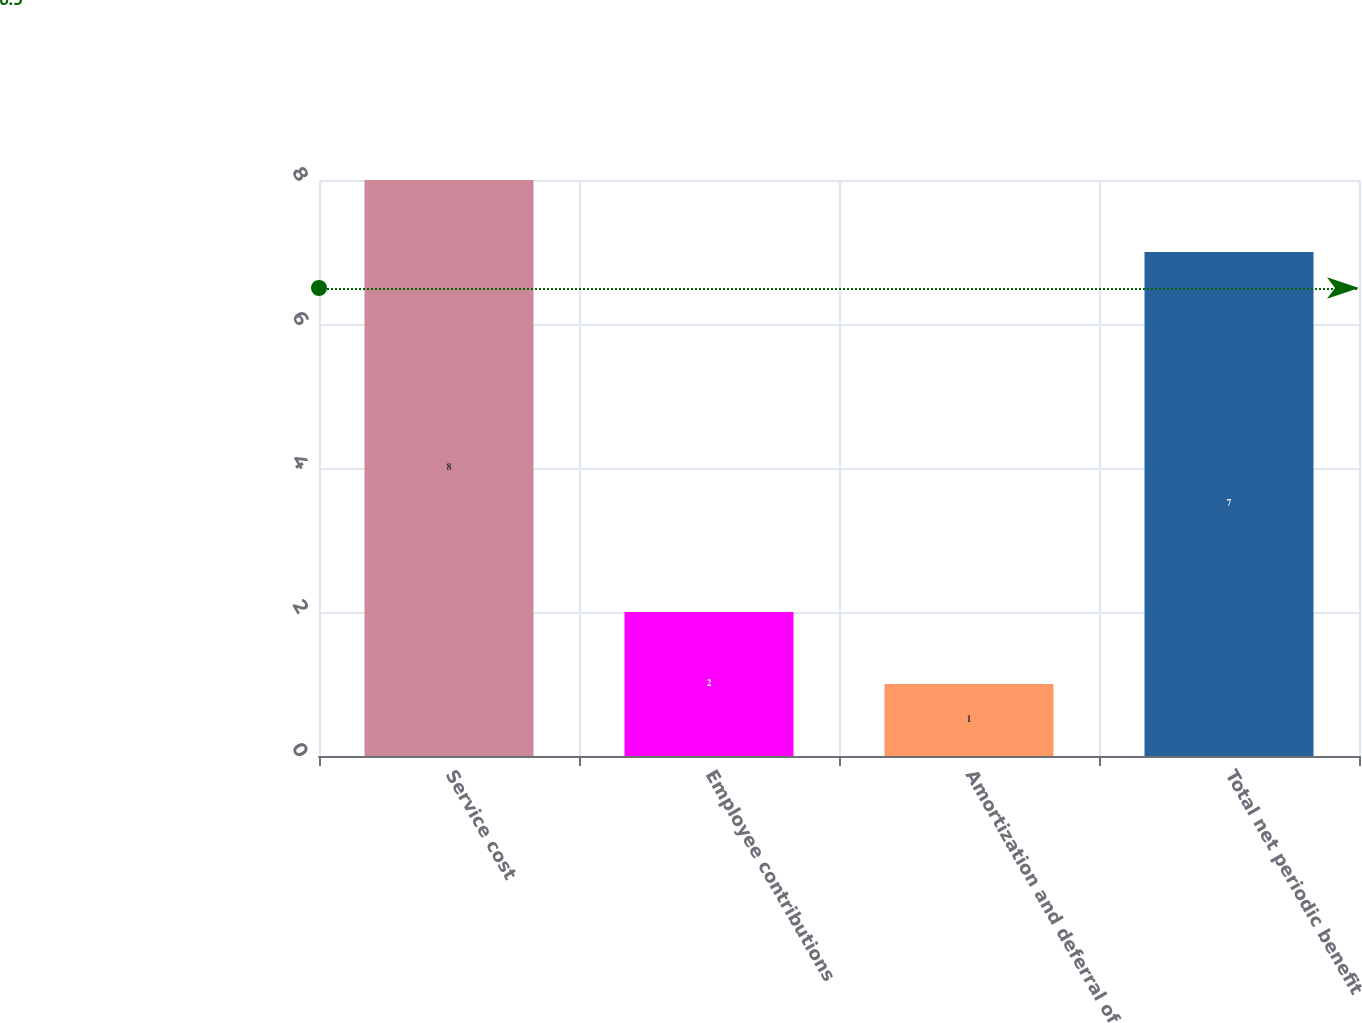Convert chart. <chart><loc_0><loc_0><loc_500><loc_500><bar_chart><fcel>Service cost<fcel>Employee contributions<fcel>Amortization and deferral of<fcel>Total net periodic benefit<nl><fcel>8<fcel>2<fcel>1<fcel>7<nl></chart> 